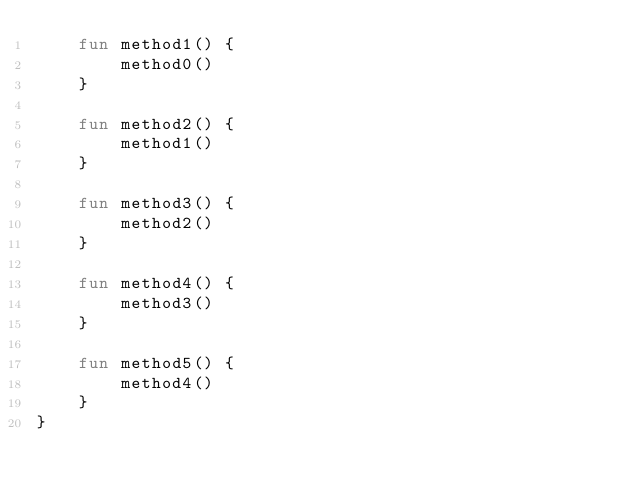Convert code to text. <code><loc_0><loc_0><loc_500><loc_500><_Kotlin_>    fun method1() {
        method0()
    }

    fun method2() {
        method1()
    }

    fun method3() {
        method2()
    }

    fun method4() {
        method3()
    }

    fun method5() {
        method4()
    }
}
</code> 